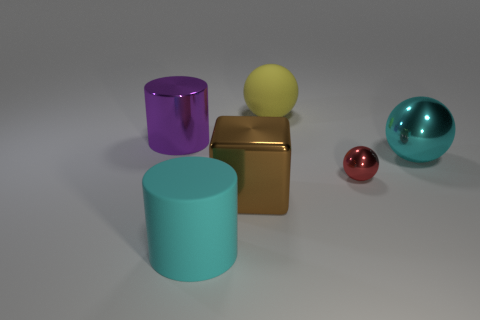Could you describe the atmosphere or mood of this image? The image has a clean, minimalist atmosphere with a serene and orderly mood. The simplicity of the shapes and the smoothness of their surfaces, combined with the soft, diffused lighting, conveys a sense of calmness and modernity. 